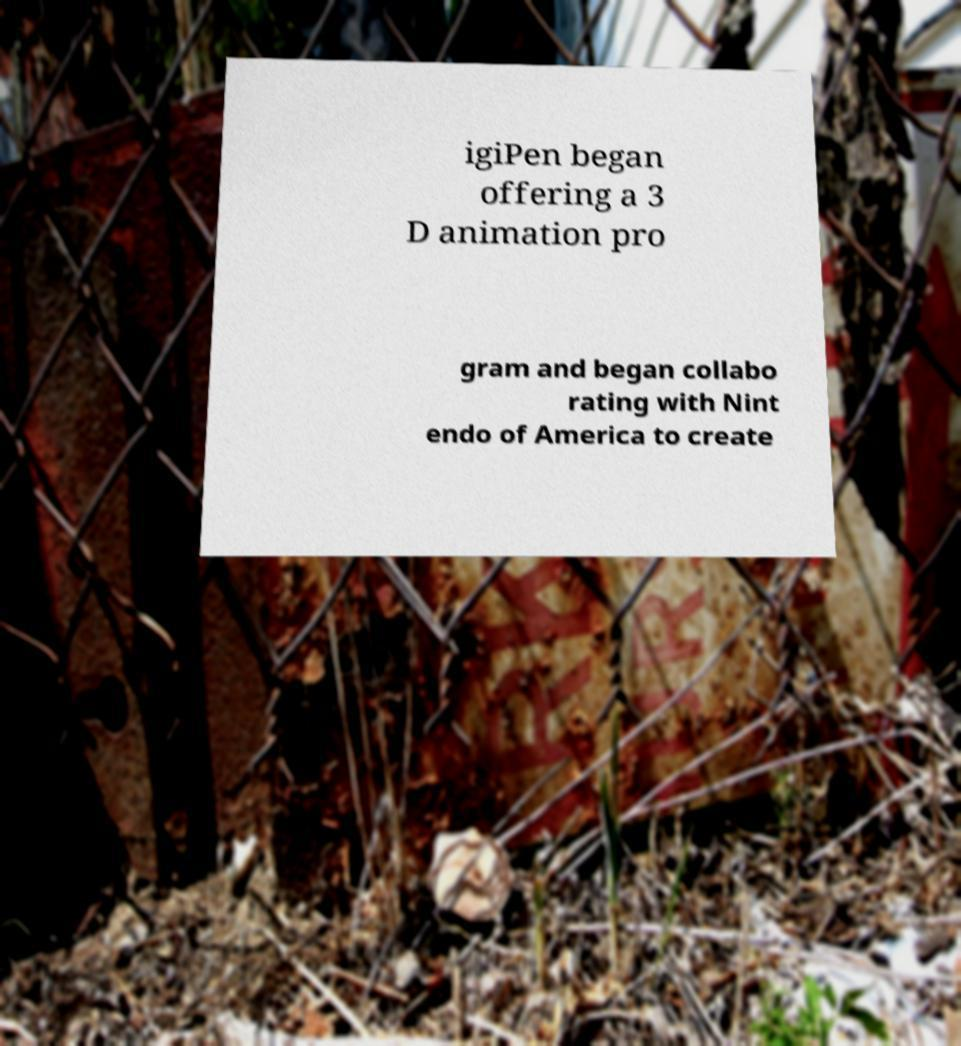There's text embedded in this image that I need extracted. Can you transcribe it verbatim? igiPen began offering a 3 D animation pro gram and began collabo rating with Nint endo of America to create 